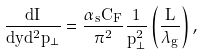<formula> <loc_0><loc_0><loc_500><loc_500>\frac { d I } { d y d ^ { 2 } p _ { \bot } } = \frac { \alpha _ { s } C _ { F } } { \pi ^ { 2 } } \frac { 1 } { p ^ { 2 } _ { \bot } } \left ( \frac { L } { \lambda _ { g } } \right ) ,</formula> 